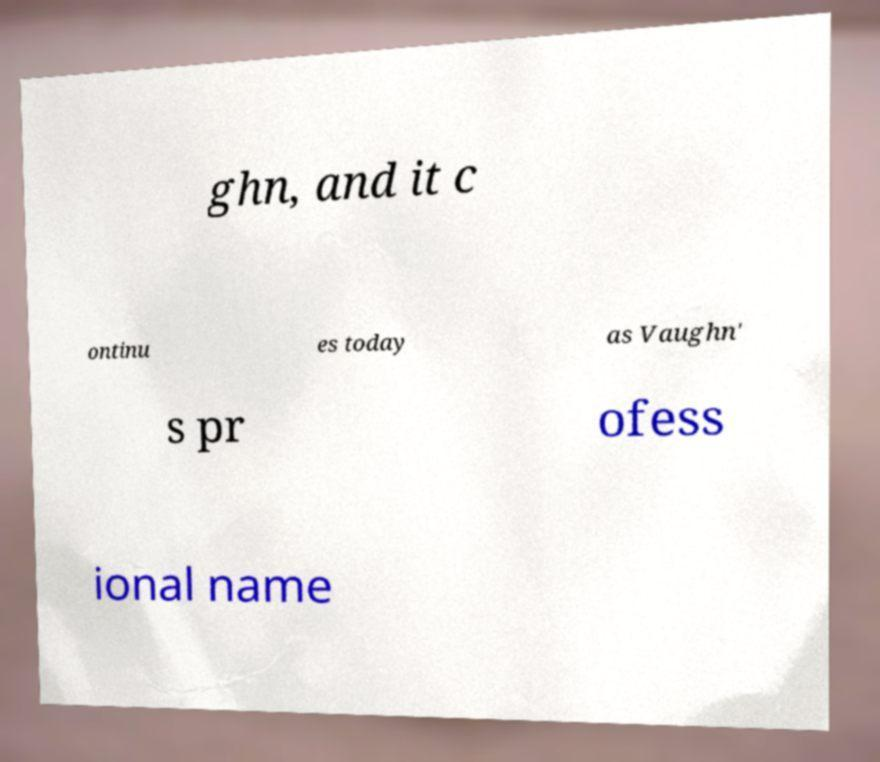For documentation purposes, I need the text within this image transcribed. Could you provide that? ghn, and it c ontinu es today as Vaughn' s pr ofess ional name 